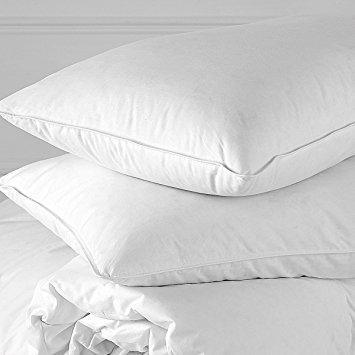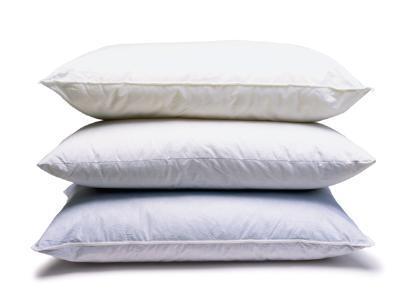The first image is the image on the left, the second image is the image on the right. For the images shown, is this caption "There are two stacks of three pillows." true? Answer yes or no. No. 